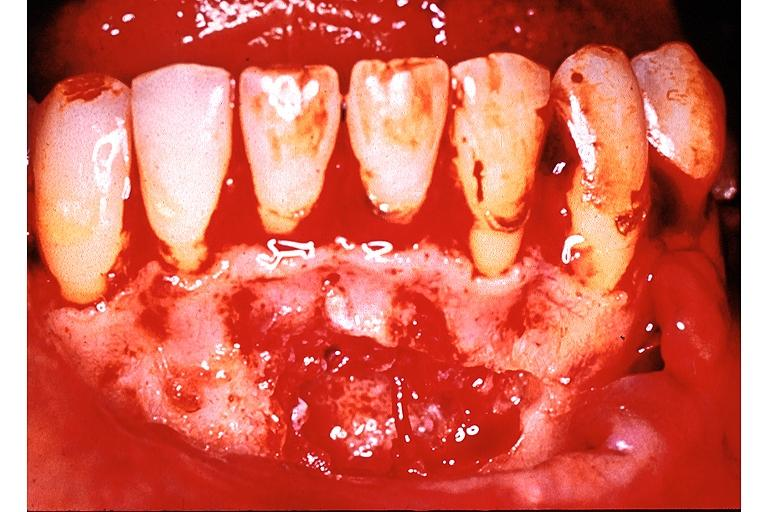what is present?
Answer the question using a single word or phrase. Oral 